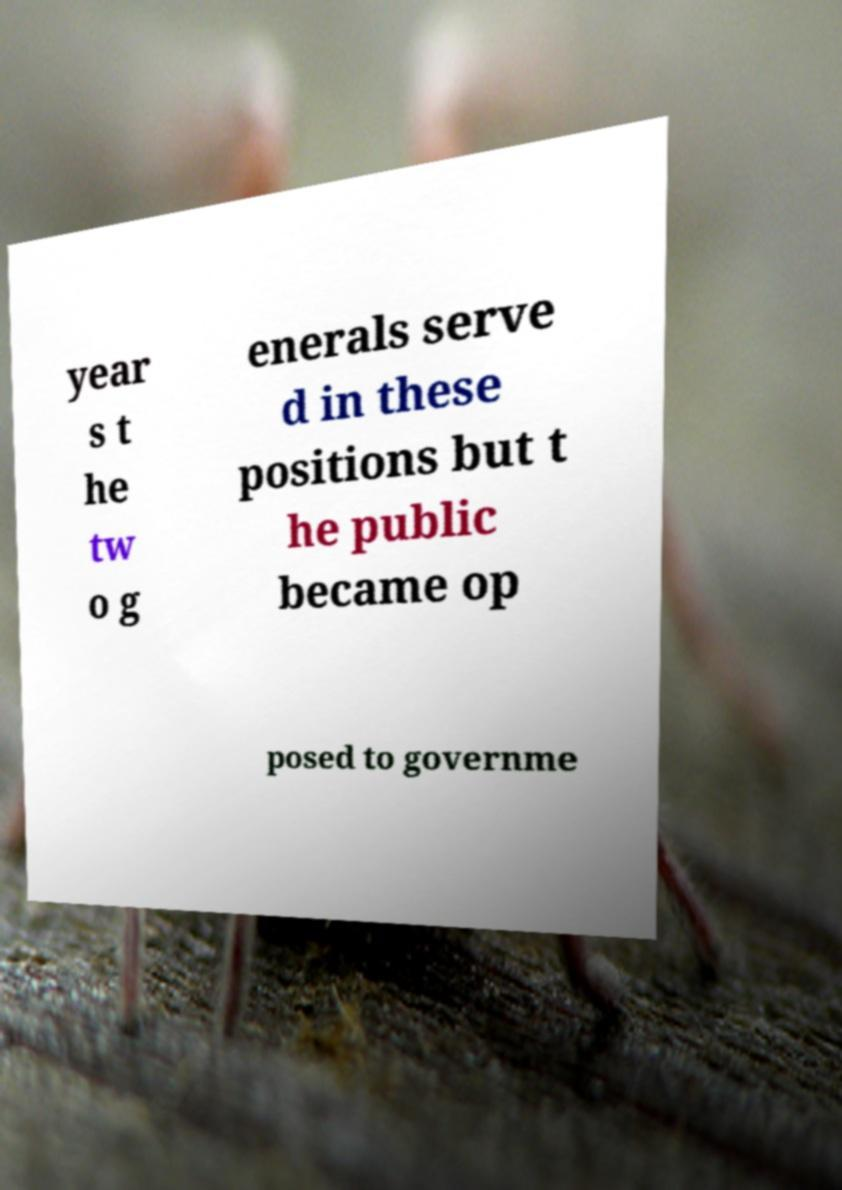Could you assist in decoding the text presented in this image and type it out clearly? year s t he tw o g enerals serve d in these positions but t he public became op posed to governme 